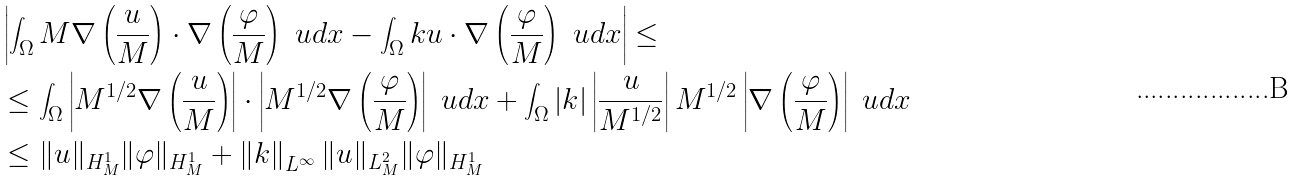<formula> <loc_0><loc_0><loc_500><loc_500>& \left | \int _ { \Omega } M \nabla \left ( \frac { u } { M } \right ) \cdot \nabla \left ( \frac { \varphi } { M } \right ) \ u d { x } - \int _ { \Omega } { k } u \cdot \nabla \left ( \frac { \varphi } { M } \right ) \ u d { x } \right | \leq \\ & \leq \int _ { \Omega } \left | M ^ { 1 / 2 } \nabla \left ( \frac { u } { M } \right ) \right | \cdot \left | M ^ { 1 / 2 } \nabla \left ( \frac { \varphi } { M } \right ) \right | \ u d { x } + \int _ { \Omega } \left | { k } \right | \left | \frac { u } { M ^ { 1 / 2 } } \right | M ^ { 1 / 2 } \left | \nabla \left ( \frac { \varphi } { M } \right ) \right | \ u d { x } \\ & \leq \| u \| _ { H _ { M } ^ { 1 } } \| \varphi \| _ { H _ { M } ^ { 1 } } + \left \| { k } \right \| _ { L ^ { \infty } } \| u \| _ { L _ { M } ^ { 2 } } \| \varphi \| _ { H _ { M } ^ { 1 } }</formula> 